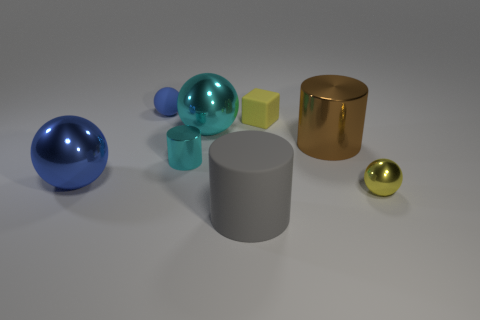Are there any big rubber objects right of the large gray thing on the left side of the small yellow metal sphere?
Offer a terse response. No. How many things are either metal cylinders that are right of the large rubber cylinder or large metal cylinders?
Provide a succinct answer. 1. Is there any other thing that is the same size as the blue shiny sphere?
Your answer should be very brief. Yes. The large cylinder that is to the right of the matte object in front of the large cyan ball is made of what material?
Provide a short and direct response. Metal. Are there an equal number of small matte balls right of the small rubber sphere and yellow rubber objects that are in front of the tiny cylinder?
Give a very brief answer. Yes. How many things are metal balls left of the tiny metallic ball or tiny spheres behind the small shiny ball?
Provide a succinct answer. 3. The cylinder that is both behind the gray rubber cylinder and on the left side of the brown metallic object is made of what material?
Ensure brevity in your answer.  Metal. There is a yellow thing that is to the left of the yellow thing that is in front of the small rubber thing that is in front of the blue rubber thing; how big is it?
Your answer should be compact. Small. Are there more brown metal cylinders than tiny brown matte objects?
Make the answer very short. Yes. Is the material of the small sphere that is behind the large cyan thing the same as the yellow ball?
Your answer should be very brief. No. 